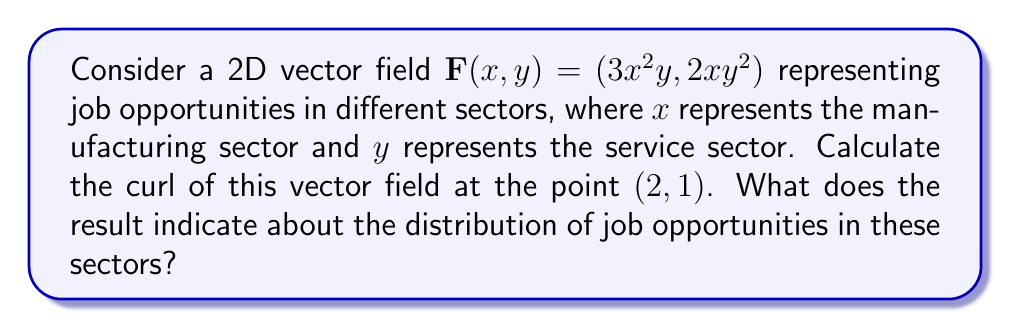Can you answer this question? To solve this problem, we'll follow these steps:

1) The curl of a 2D vector field $\mathbf{F}(x,y) = (P(x,y), Q(x,y))$ is given by:

   $$\text{curl } \mathbf{F} = \frac{\partial Q}{\partial x} - \frac{\partial P}{\partial y}$$

2) In our case, $P(x,y) = 3x^2y$ and $Q(x,y) = 2xy^2$

3) Let's calculate the partial derivatives:

   $$\frac{\partial Q}{\partial x} = \frac{\partial}{\partial x}(2xy^2) = 2y^2$$

   $$\frac{\partial P}{\partial y} = \frac{\partial}{\partial y}(3x^2y) = 3x^2$$

4) Now we can calculate the curl:

   $$\text{curl } \mathbf{F} = \frac{\partial Q}{\partial x} - \frac{\partial P}{\partial y} = 2y^2 - 3x^2$$

5) Evaluate this at the point (2,1):

   $$\text{curl } \mathbf{F}(2,1) = 2(1)^2 - 3(2)^2 = 2 - 12 = -10$$

6) Interpretation: The negative curl indicates a clockwise rotation in the job opportunity distribution. This suggests that as we move from the manufacturing sector to the service sector, there's a tendency for job opportunities to shift back towards manufacturing. The magnitude of 10 indicates a significant imbalance in this distribution.
Answer: $-10$ 